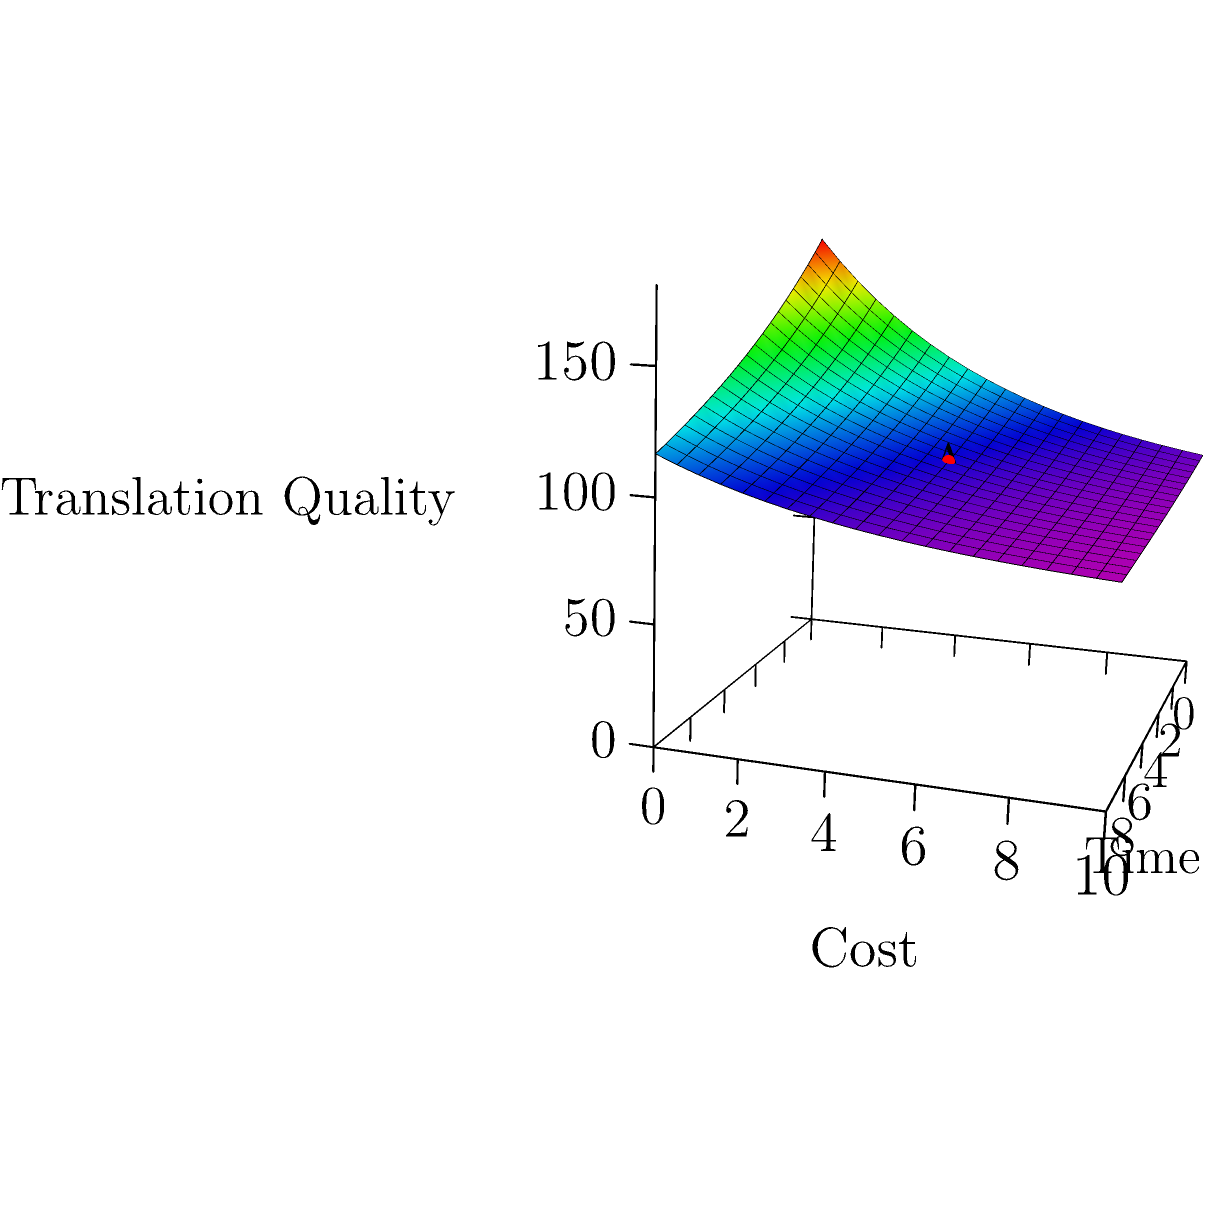As a project manager overseeing language service providers, you're analyzing a surface plot that represents translation quality as a function of time and cost. At point A (5,5) on the surface, what does the gradient vector indicate about the rate of change in translation quality with respect to time and cost? To answer this question, we need to follow these steps:

1) The gradient of a function $f(x,y)$ at a point $(a,b)$ is given by:

   $\nabla f(a,b) = \left(\frac{\partial f}{\partial x}(a,b), \frac{\partial f}{\partial y}(a,b)\right)$

2) In this case, our function is:

   $f(x,y) = 100e^{-0.1x-0.2y} + 80$

3) We need to calculate the partial derivatives:

   $\frac{\partial f}{\partial x} = -10e^{-0.1x-0.2y}$
   $\frac{\partial f}{\partial y} = -20e^{-0.1x-0.2y}$

4) At point A (5,5), we evaluate these partial derivatives:

   $\frac{\partial f}{\partial x}(5,5) = -10e^{-0.1(5)-0.2(5)} \approx -3.68$
   $\frac{\partial f}{\partial y}(5,5) = -20e^{-0.1(5)-0.2(5)} \approx -7.36$

5) Therefore, the gradient vector at point A is approximately:

   $\nabla f(5,5) \approx (-3.68, -7.36)$

6) Interpreting this result:
   - The negative x-component (-3.68) indicates that translation quality decreases as time increases.
   - The negative y-component (-7.36) indicates that translation quality decreases as cost increases.
   - The magnitude of the y-component is larger, suggesting that changes in cost have a greater impact on quality than changes in time at this point.
Answer: Translation quality decreases with both time and cost, with cost having a greater impact (gradient ≈ (-3.68, -7.36)). 